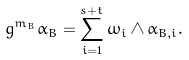<formula> <loc_0><loc_0><loc_500><loc_500>g ^ { m _ { B } } \alpha _ { B } = \sum _ { i = 1 } ^ { s + t } \omega _ { i } \wedge \alpha _ { B , i } .</formula> 